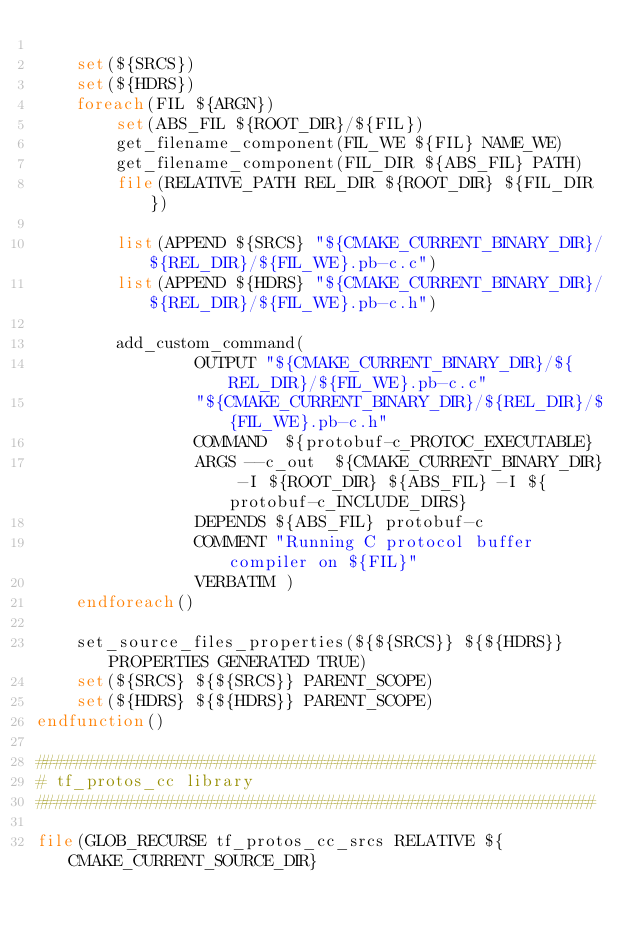Convert code to text. <code><loc_0><loc_0><loc_500><loc_500><_CMake_>
    set(${SRCS})
    set(${HDRS})
    foreach(FIL ${ARGN})
        set(ABS_FIL ${ROOT_DIR}/${FIL})
        get_filename_component(FIL_WE ${FIL} NAME_WE)
        get_filename_component(FIL_DIR ${ABS_FIL} PATH)
        file(RELATIVE_PATH REL_DIR ${ROOT_DIR} ${FIL_DIR})

        list(APPEND ${SRCS} "${CMAKE_CURRENT_BINARY_DIR}/${REL_DIR}/${FIL_WE}.pb-c.c")
        list(APPEND ${HDRS} "${CMAKE_CURRENT_BINARY_DIR}/${REL_DIR}/${FIL_WE}.pb-c.h")

        add_custom_command(
                OUTPUT "${CMAKE_CURRENT_BINARY_DIR}/${REL_DIR}/${FIL_WE}.pb-c.c"
                "${CMAKE_CURRENT_BINARY_DIR}/${REL_DIR}/${FIL_WE}.pb-c.h"
                COMMAND  ${protobuf-c_PROTOC_EXECUTABLE}
                ARGS --c_out  ${CMAKE_CURRENT_BINARY_DIR} -I ${ROOT_DIR} ${ABS_FIL} -I ${protobuf-c_INCLUDE_DIRS}
                DEPENDS ${ABS_FIL} protobuf-c
                COMMENT "Running C protocol buffer compiler on ${FIL}"
                VERBATIM )
    endforeach()

    set_source_files_properties(${${SRCS}} ${${HDRS}} PROPERTIES GENERATED TRUE)
    set(${SRCS} ${${SRCS}} PARENT_SCOPE)
    set(${HDRS} ${${HDRS}} PARENT_SCOPE)
endfunction()

########################################################
# tf_protos_cc library
########################################################

file(GLOB_RECURSE tf_protos_cc_srcs RELATIVE ${CMAKE_CURRENT_SOURCE_DIR}</code> 